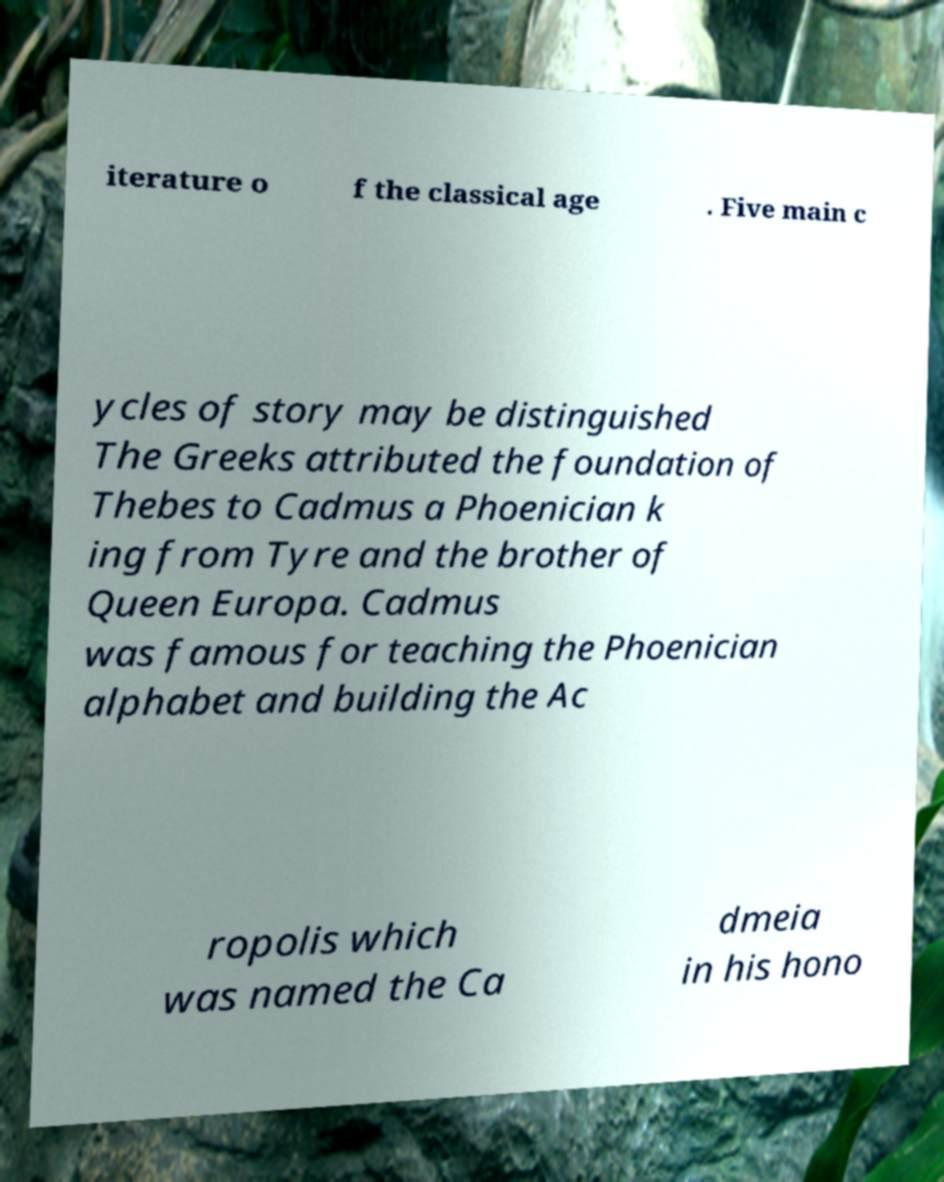Please read and relay the text visible in this image. What does it say? iterature o f the classical age . Five main c ycles of story may be distinguished The Greeks attributed the foundation of Thebes to Cadmus a Phoenician k ing from Tyre and the brother of Queen Europa. Cadmus was famous for teaching the Phoenician alphabet and building the Ac ropolis which was named the Ca dmeia in his hono 